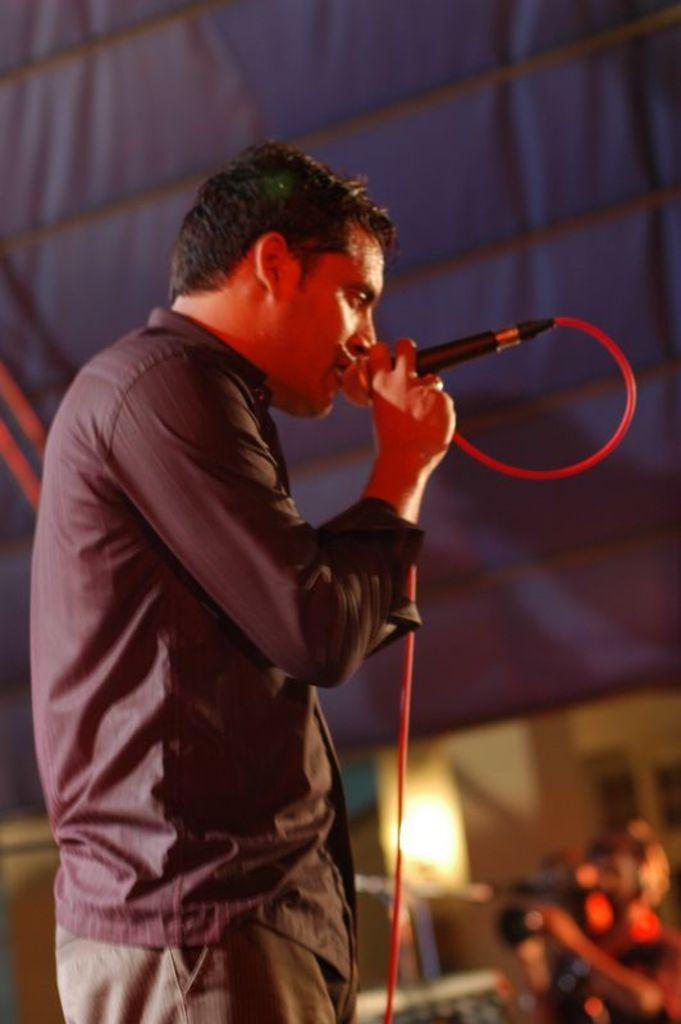What is the main subject of the image? There is a person in the image. What is the person doing in the image? The person is singing in the microphone. Can you describe the person's attire? The person is wearing a shirt. Who else is present in the image? There is a person holding a camera in the image. How many friends are visible in the image? There is no mention of friends in the image, so we cannot determine their presence or number. What type of cracker is being used as a prop in the image? There is no cracker present in the image. 